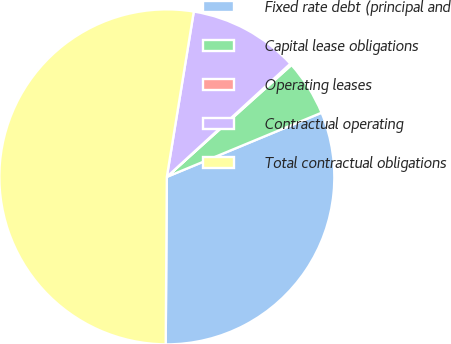<chart> <loc_0><loc_0><loc_500><loc_500><pie_chart><fcel>Fixed rate debt (principal and<fcel>Capital lease obligations<fcel>Operating leases<fcel>Contractual operating<fcel>Total contractual obligations<nl><fcel>31.36%<fcel>5.39%<fcel>0.16%<fcel>10.62%<fcel>52.46%<nl></chart> 